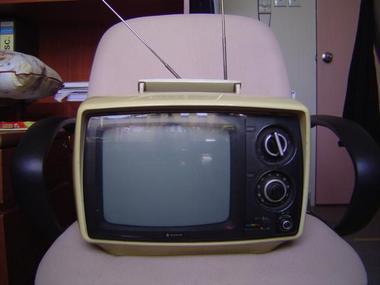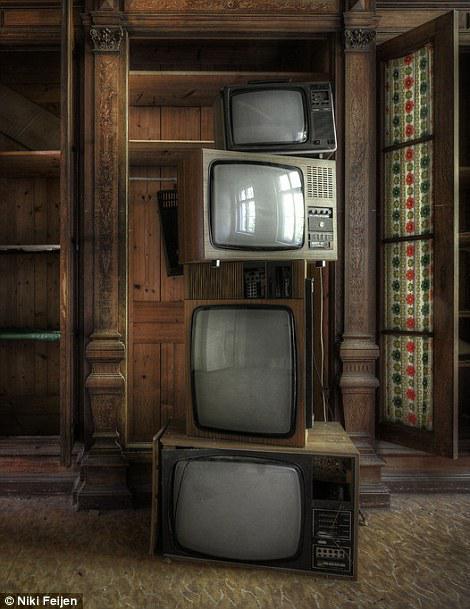The first image is the image on the left, the second image is the image on the right. Assess this claim about the two images: "Each image contains at least one stack that includes multiple different models of old-fashioned TV sets.". Correct or not? Answer yes or no. No. 